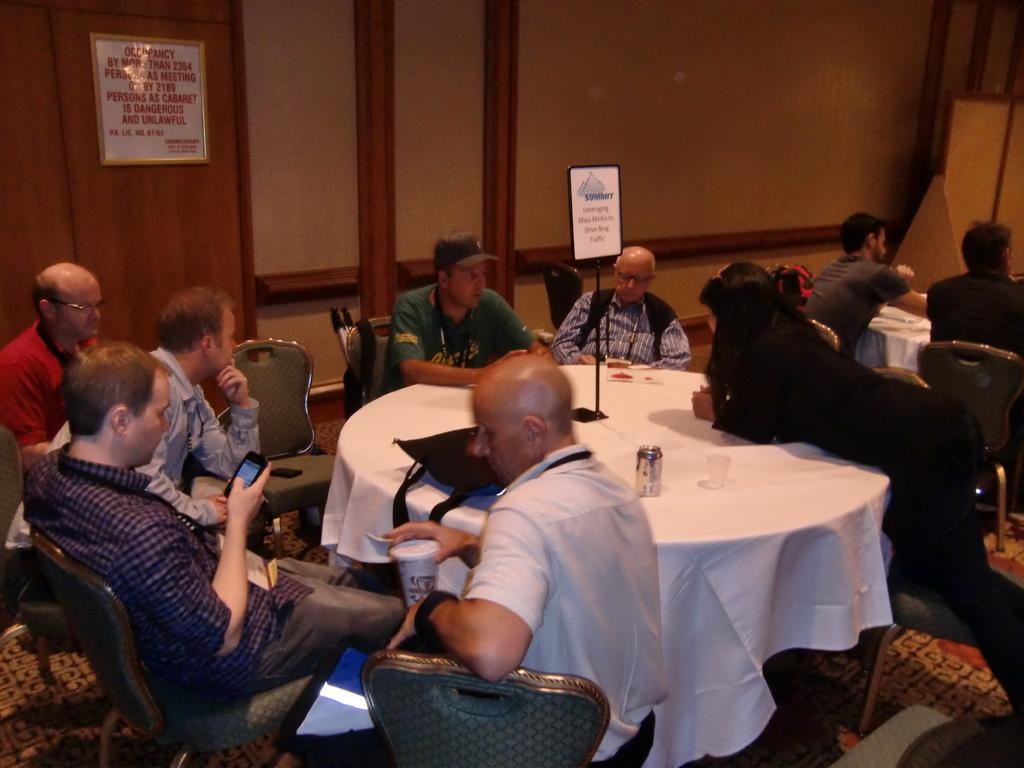How many people are in the image? There are many people in the image. What are the people doing in the image? The people are sitting around a table. Can you describe anything on the wall in the background of the image? There is a frame on the wall in the background of the image. What type of humor is being shared by the people around the table in the image? There is no indication of humor being shared in the image; it only shows people sitting around a table. 